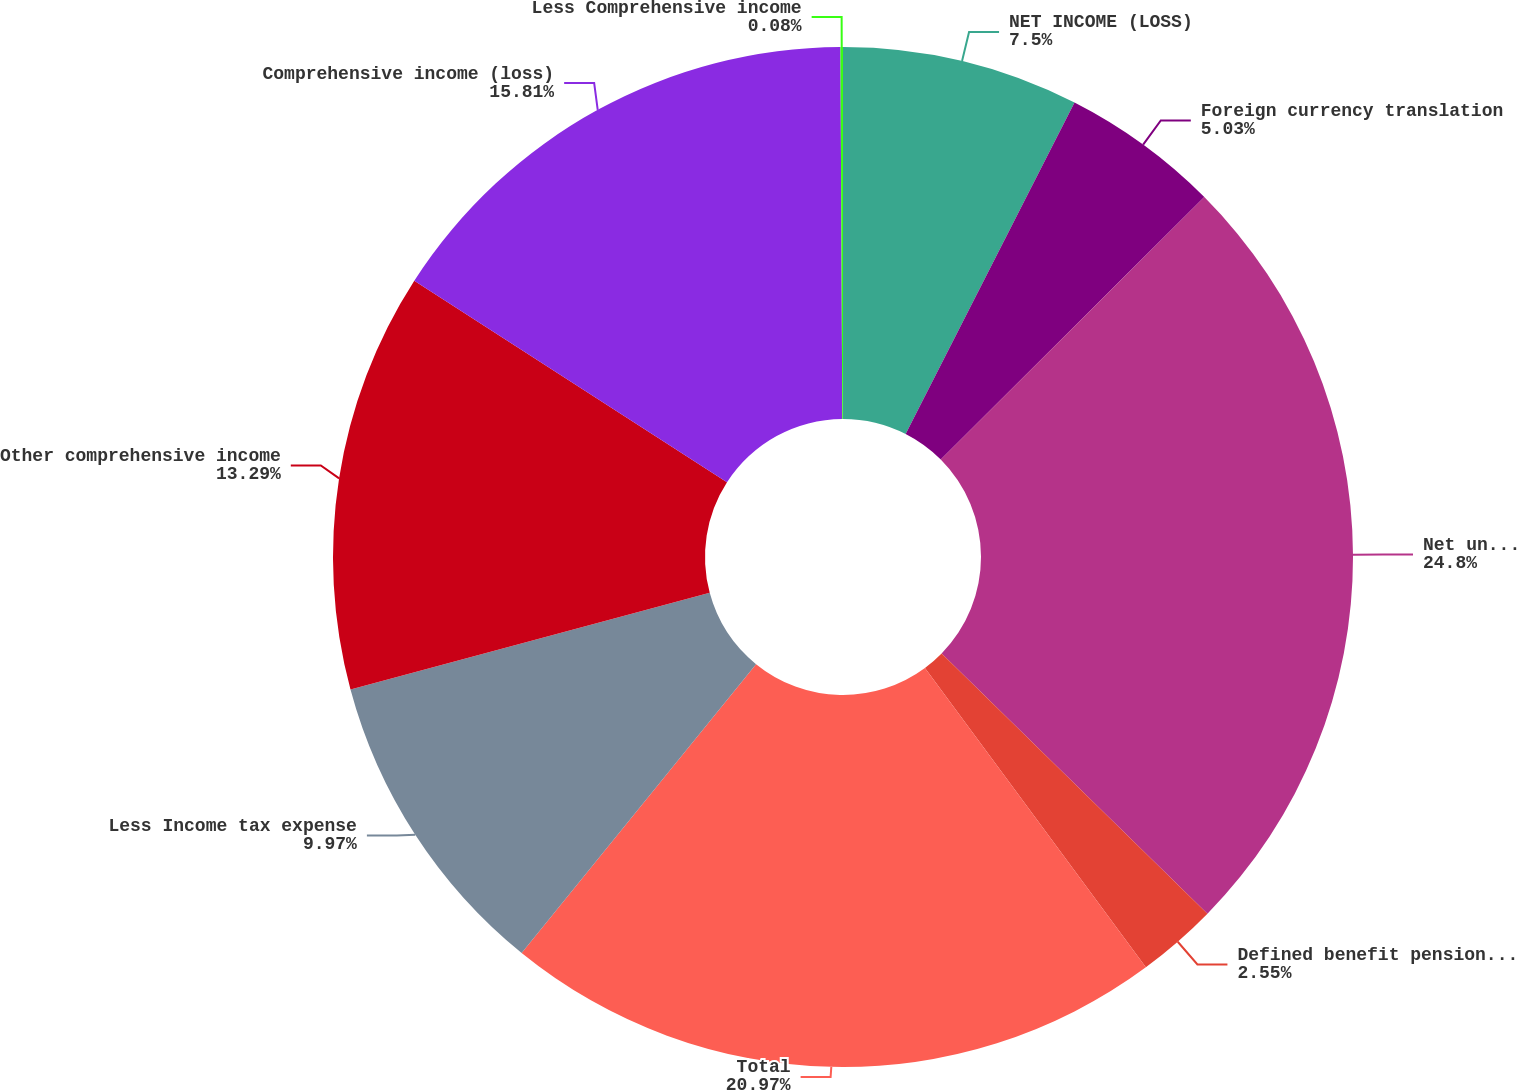<chart> <loc_0><loc_0><loc_500><loc_500><pie_chart><fcel>NET INCOME (LOSS)<fcel>Foreign currency translation<fcel>Net unrealized investment<fcel>Defined benefit pension and<fcel>Total<fcel>Less Income tax expense<fcel>Other comprehensive income<fcel>Comprehensive income (loss)<fcel>Less Comprehensive income<nl><fcel>7.5%<fcel>5.03%<fcel>24.8%<fcel>2.55%<fcel>20.97%<fcel>9.97%<fcel>13.29%<fcel>15.81%<fcel>0.08%<nl></chart> 